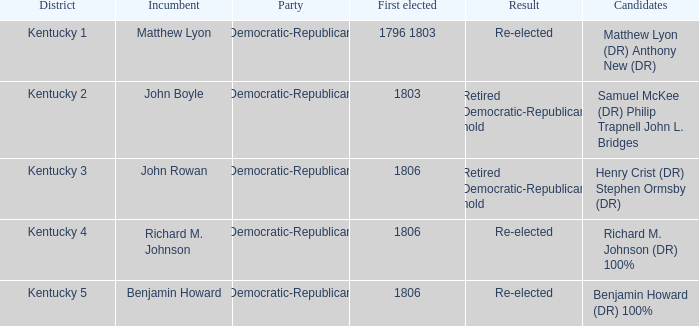Name the foremost elected individual for kentucky. 1796 1803. 